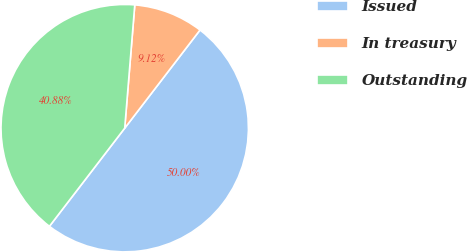Convert chart. <chart><loc_0><loc_0><loc_500><loc_500><pie_chart><fcel>Issued<fcel>In treasury<fcel>Outstanding<nl><fcel>50.0%<fcel>9.12%<fcel>40.88%<nl></chart> 